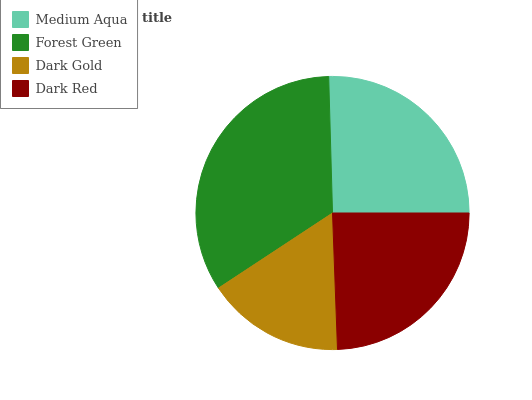Is Dark Gold the minimum?
Answer yes or no. Yes. Is Forest Green the maximum?
Answer yes or no. Yes. Is Forest Green the minimum?
Answer yes or no. No. Is Dark Gold the maximum?
Answer yes or no. No. Is Forest Green greater than Dark Gold?
Answer yes or no. Yes. Is Dark Gold less than Forest Green?
Answer yes or no. Yes. Is Dark Gold greater than Forest Green?
Answer yes or no. No. Is Forest Green less than Dark Gold?
Answer yes or no. No. Is Medium Aqua the high median?
Answer yes or no. Yes. Is Dark Red the low median?
Answer yes or no. Yes. Is Dark Red the high median?
Answer yes or no. No. Is Forest Green the low median?
Answer yes or no. No. 